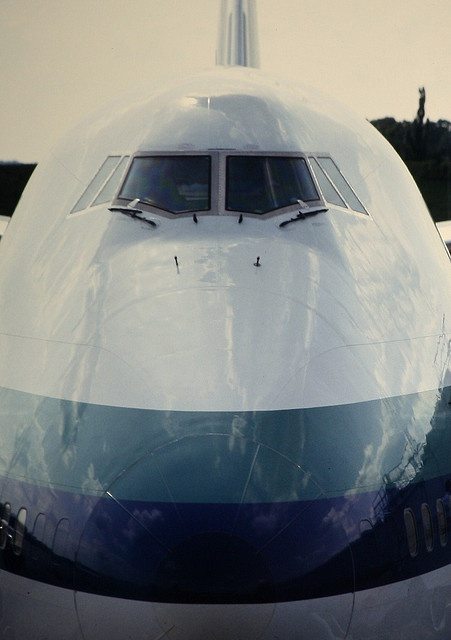Describe the objects in this image and their specific colors. I can see a airplane in darkgray, black, lightgray, and gray tones in this image. 